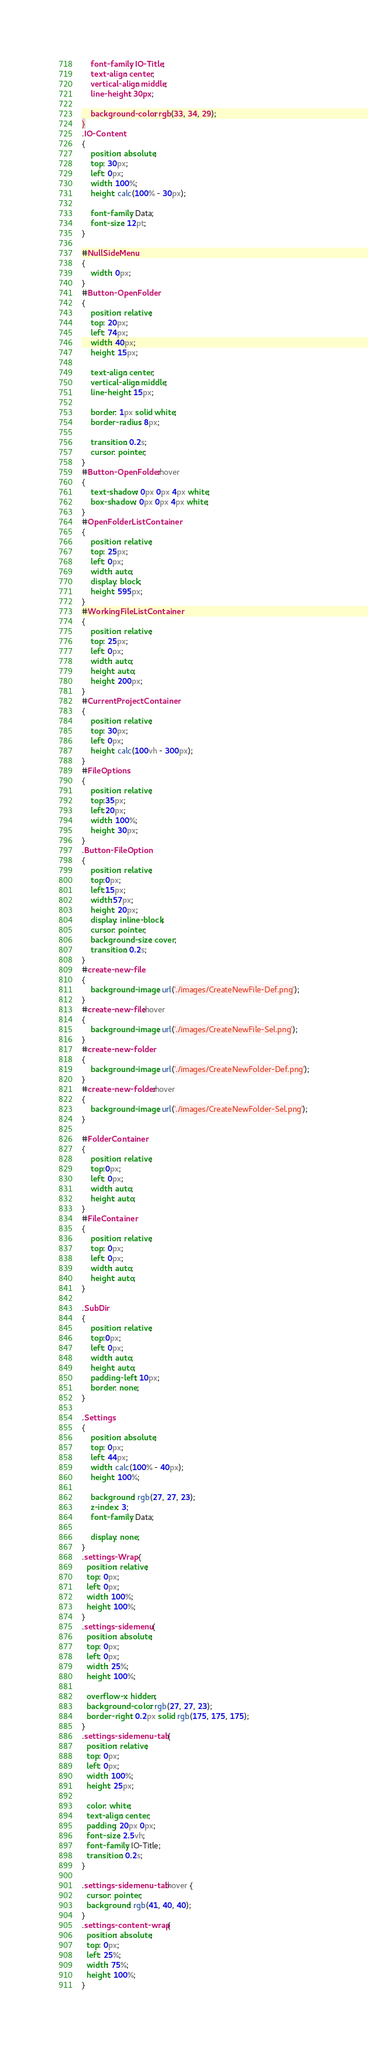Convert code to text. <code><loc_0><loc_0><loc_500><loc_500><_CSS_>    font-family: IO-Title;
    text-align: center;
    vertical-align: middle;
    line-height: 30px;
    
    background-color: rgb(33, 34, 29);
}
.IO-Content
{
    position: absolute;
    top: 30px;
    left: 0px;
    width: 100%;
    height: calc(100% - 30px);

    font-family: Data;
    font-size: 12pt;
}

#NullSideMenu
{
    width: 0px;
}
#Button-OpenFolder
{
    position: relative;
    top: 20px;
    left: 74px;
    width: 40px;
    height: 15px;

    text-align: center;
    vertical-align: middle;
    line-height: 15px;

    border: 1px solid white;
    border-radius: 8px;

    transition: 0.2s;
    cursor: pointer;
}
#Button-OpenFolder:hover
{
    text-shadow: 0px 0px 4px white;    
    box-shadow: 0px 0px 4px white;
}
#OpenFolderListContainer
{
    position: relative;
    top: 25px;
    left: 0px;
    width: auto;
    display: block;
    height: 595px;
}
#WorkingFileListContainer
{
    position: relative;
    top: 25px;
    left: 0px;
    width: auto;
    height: auto;
    height: 200px;
}
#CurrentProjectContainer
{
    position: relative;
    top: 30px;
    left: 0px;
    height: calc(100vh - 300px);
}
#FileOptions
{
    position: relative;
    top:35px;
    left:20px;
    width: 100%;
    height: 30px;
}
.Button-FileOption
{
    position: relative;
    top:0px;
    left:15px;
    width:57px;
    height: 20px;
    display: inline-block;
    cursor: pointer;
    background-size: cover;        
    transition: 0.2s;
}
#create-new-file 
{
    background-image: url('./images/CreateNewFile-Def.png');
}
#create-new-file:hover
{
    background-image: url('./images/CreateNewFile-Sel.png');    
}
#create-new-folder
{
    background-image: url('./images/CreateNewFolder-Def.png');
}
#create-new-folder:hover
{
    background-image: url('./images/CreateNewFolder-Sel.png');
}

#FolderContainer
{
    position: relative;
    top:0px;
    left: 0px;
    width: auto;
    height: auto;
}
#FileContainer
{
    position: relative;
    top: 0px;
    left: 0px;
    width: auto;
    height: auto;
}

.SubDir
{
    position: relative;
    top:0px;
    left: 0px;
    width: auto;
    height: auto;
    padding-left: 10px;
    border: none;
}

.Settings
{
    position: absolute;
    top: 0px;
    left: 44px;
    width: calc(100% - 40px);
    height: 100%;

    background: rgb(27, 27, 23);
    z-index: 3;
    font-family: Data;

    display: none;
}
.settings-Wrap {
  position: relative;
  top: 0px;
  left: 0px;
  width: 100%;
  height: 100%;
}
.settings-sidemenu {
  position: absolute; 
  top: 0px;
  left: 0px;
  width: 25%; 
  height: 100%;

  overflow-x: hidden;
  background-color: rgb(27, 27, 23);
  border-right: 0.2px solid rgb(175, 175, 175);
}
.settings-sidemenu-tab {
  position: relative;
  top: 0px;
  left: 0px;
  width: 100%;
  height: 25px;

  color: white;
  text-align: center;
  padding: 20px 0px;
  font-size: 2.5vh;
  font-family: IO-Title;
  transition: 0.2s;
}

.settings-sidemenu-tab:hover {
  cursor: pointer;
  background: rgb(41, 40, 40);
}
.settings-content-wrap {
  position: absolute; 
  top: 0px; 
  left: 25%; 
  width: 75%; 
  height: 100%;
}
</code> 